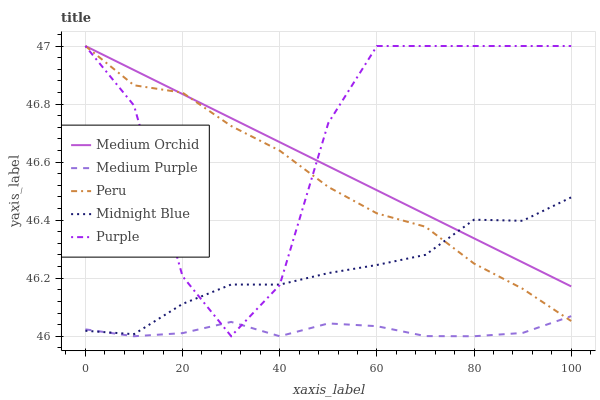Does Medium Purple have the minimum area under the curve?
Answer yes or no. Yes. Does Purple have the maximum area under the curve?
Answer yes or no. Yes. Does Medium Orchid have the minimum area under the curve?
Answer yes or no. No. Does Medium Orchid have the maximum area under the curve?
Answer yes or no. No. Is Medium Orchid the smoothest?
Answer yes or no. Yes. Is Purple the roughest?
Answer yes or no. Yes. Is Purple the smoothest?
Answer yes or no. No. Is Medium Orchid the roughest?
Answer yes or no. No. Does Purple have the lowest value?
Answer yes or no. No. Does Peru have the highest value?
Answer yes or no. Yes. Does Midnight Blue have the highest value?
Answer yes or no. No. Is Medium Purple less than Medium Orchid?
Answer yes or no. Yes. Is Medium Orchid greater than Medium Purple?
Answer yes or no. Yes. Does Medium Purple intersect Midnight Blue?
Answer yes or no. Yes. Is Medium Purple less than Midnight Blue?
Answer yes or no. No. Is Medium Purple greater than Midnight Blue?
Answer yes or no. No. Does Medium Purple intersect Medium Orchid?
Answer yes or no. No. 